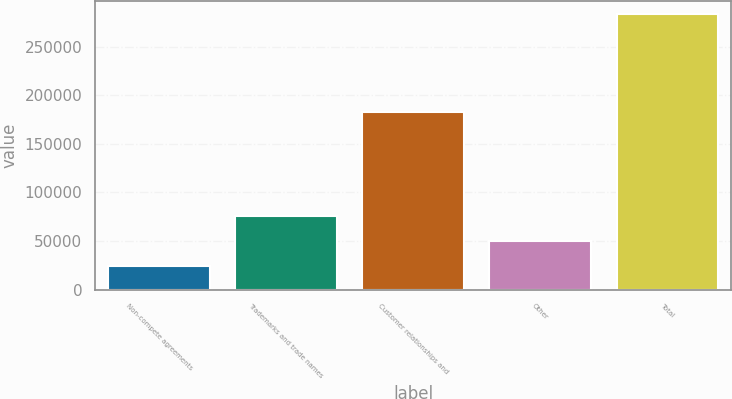Convert chart to OTSL. <chart><loc_0><loc_0><loc_500><loc_500><bar_chart><fcel>Non-compete agreements<fcel>Trademarks and trade names<fcel>Customer relationships and<fcel>Other<fcel>Total<nl><fcel>23874<fcel>75758.2<fcel>183051<fcel>49816.1<fcel>283295<nl></chart> 